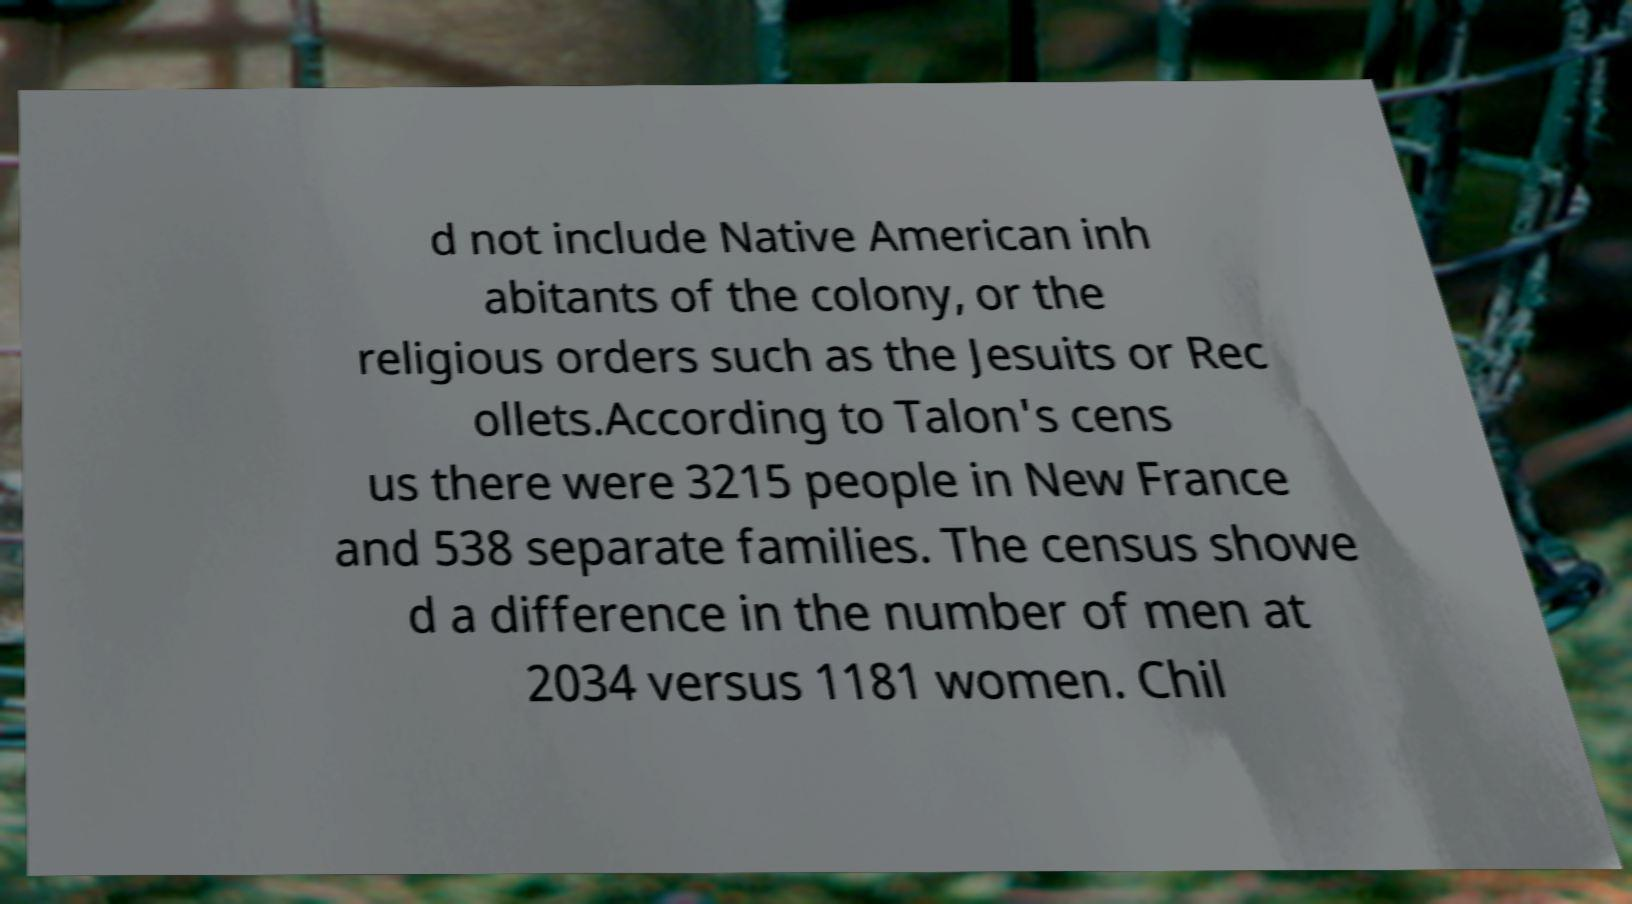What messages or text are displayed in this image? I need them in a readable, typed format. d not include Native American inh abitants of the colony, or the religious orders such as the Jesuits or Rec ollets.According to Talon's cens us there were 3215 people in New France and 538 separate families. The census showe d a difference in the number of men at 2034 versus 1181 women. Chil 